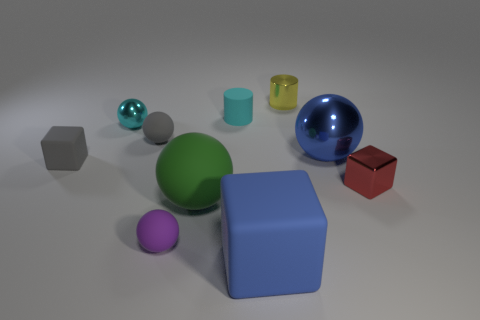How many rubber things are blue things or large green balls?
Your answer should be very brief. 2. Are there more gray things than large things?
Provide a succinct answer. No. What is the size of the rubber thing that is the same color as the large metal ball?
Give a very brief answer. Large. There is a tiny object that is in front of the big matte thing behind the blue cube; what is its shape?
Keep it short and to the point. Sphere. There is a small cube that is on the right side of the rubber cube in front of the small red metal object; is there a large cube in front of it?
Give a very brief answer. Yes. The other matte object that is the same size as the green rubber object is what color?
Offer a terse response. Blue. There is a object that is both in front of the green sphere and left of the large blue matte block; what is its shape?
Provide a succinct answer. Sphere. There is a yellow cylinder that is on the right side of the large blue object on the left side of the yellow metal cylinder; how big is it?
Your answer should be compact. Small. How many tiny shiny balls are the same color as the tiny rubber cylinder?
Offer a terse response. 1. How many other objects are the same size as the gray rubber cube?
Make the answer very short. 6. 